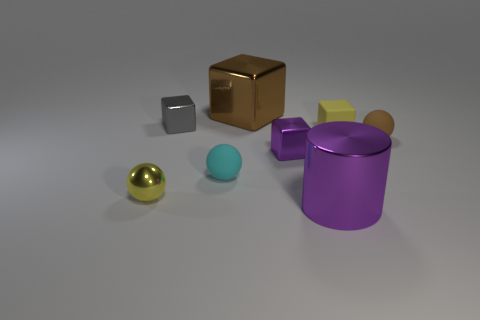Subtract all large cubes. How many cubes are left? 3 Subtract all purple cubes. How many cubes are left? 3 Add 1 cyan rubber balls. How many objects exist? 9 Subtract 1 gray blocks. How many objects are left? 7 Subtract all cylinders. How many objects are left? 7 Subtract 1 cubes. How many cubes are left? 3 Subtract all yellow cylinders. Subtract all blue balls. How many cylinders are left? 1 Subtract all gray blocks. How many blue cylinders are left? 0 Subtract all green blocks. Subtract all yellow cubes. How many objects are left? 7 Add 6 tiny matte things. How many tiny matte things are left? 9 